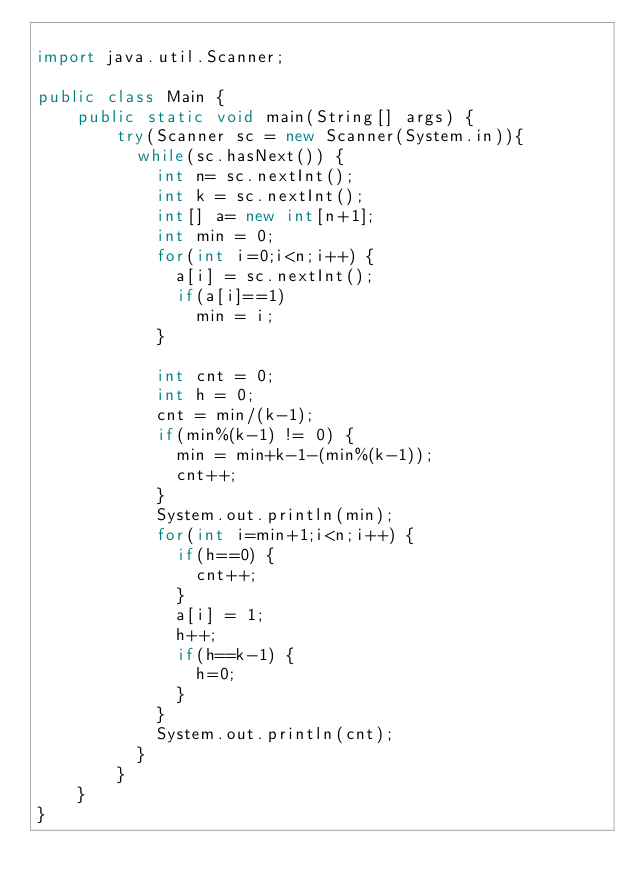Convert code to text. <code><loc_0><loc_0><loc_500><loc_500><_Java_>
import java.util.Scanner;
 
public class Main {
    public static void main(String[] args) {
        try(Scanner sc = new Scanner(System.in)){
        	while(sc.hasNext()) {
        		int n= sc.nextInt();
        		int k = sc.nextInt();
        		int[] a= new int[n+1];
        		int min = 0;
        		for(int i=0;i<n;i++) {
        			a[i] = sc.nextInt();
        			if(a[i]==1)
        				min = i;
        		}
        		
        		int cnt = 0;
        		int h = 0;
        		cnt = min/(k-1);
        		if(min%(k-1) != 0) {
        			min = min+k-1-(min%(k-1));
        			cnt++;
        		}
        		System.out.println(min);
       			for(int i=min+1;i<n;i++) {
       				if(h==0) {
       					cnt++;
       				}
       				a[i] = 1;
       				h++;
       				if(h==k-1) {
       					h=0;
       				}
        		}
       			System.out.println(cnt);
        	}
        }
    }
}


</code> 